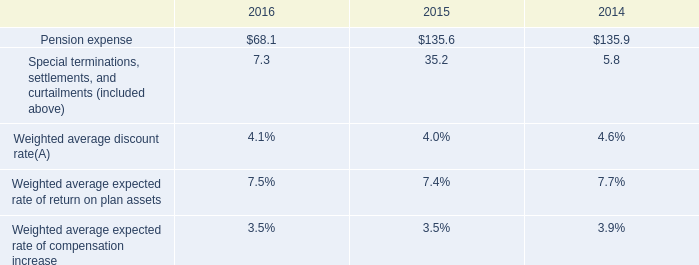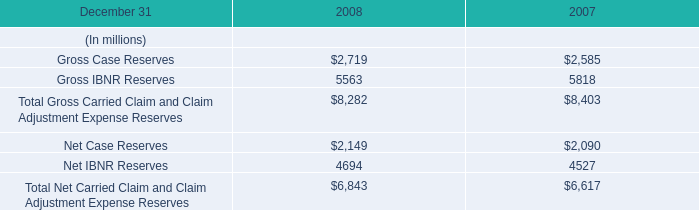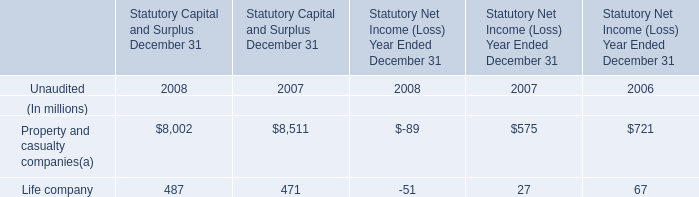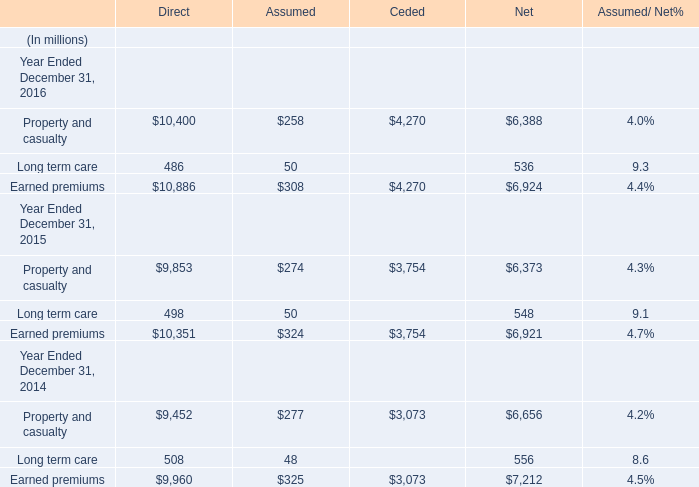What is the growing rate of Long term care in the year with the least Property and casualty? 
Computations: ((((498 + 50) + 548) - ((508 + 48) + 556)) / ((508 + 48) + 556))
Answer: -0.01439. 